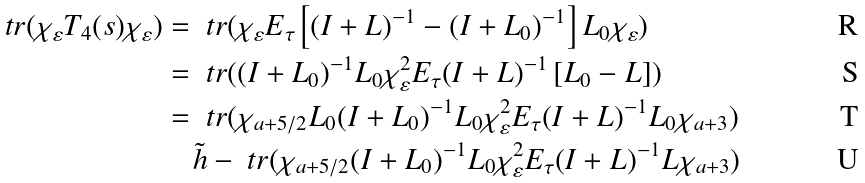<formula> <loc_0><loc_0><loc_500><loc_500>\ t r ( \chi _ { \varepsilon } T _ { 4 } ( s ) \chi _ { \varepsilon } ) & = \ t r ( \chi _ { \varepsilon } E _ { \tau } \left [ ( I + L ) ^ { - 1 } - ( I + L _ { 0 } ) ^ { - 1 } \right ] L _ { 0 } \chi _ { \varepsilon } ) \\ & = \ t r ( ( I + L _ { 0 } ) ^ { - 1 } L _ { 0 } \chi _ { \varepsilon } ^ { 2 } E _ { \tau } ( I + L ) ^ { - 1 } \left [ L _ { 0 } - L \right ] ) \\ & = \ t r ( \chi _ { a + 5 / 2 } L _ { 0 } ( I + L _ { 0 } ) ^ { - 1 } L _ { 0 } \chi _ { \varepsilon } ^ { 2 } E _ { \tau } ( I + L ) ^ { - 1 } L _ { 0 } \chi _ { a + 3 } ) \\ & \quad \tilde { h } - \ t r ( \chi _ { a + 5 / 2 } ( I + L _ { 0 } ) ^ { - 1 } L _ { 0 } \chi _ { \varepsilon } ^ { 2 } E _ { \tau } ( I + L ) ^ { - 1 } L \chi _ { a + 3 } )</formula> 